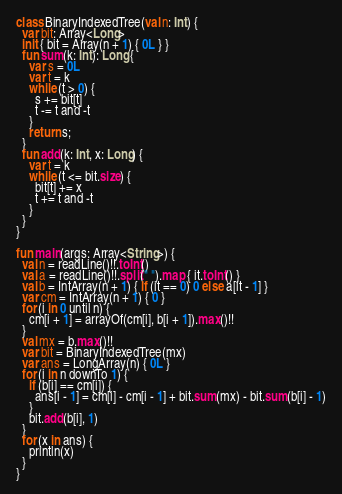<code> <loc_0><loc_0><loc_500><loc_500><_Kotlin_>class BinaryIndexedTree(val n: Int) {
  var bit: Array<Long>
  init { bit = Array(n + 1) { 0L } }
  fun sum(k: Int): Long {
    var s = 0L
    var t = k
    while (t > 0) {
      s += bit[t]
      t -= t and -t
    }
    return s;
  }
  fun add(k: Int, x: Long) {
    var t = k
    while (t <= bit.size) {
      bit[t] += x
      t += t and -t
    }
  }
}

fun main(args: Array<String>) {
  val n = readLine()!!.toInt()
  val a = readLine()!!.split(" ").map { it.toInt() }
  val b = IntArray(n + 1) { if (it == 0) 0 else a[it - 1] }
  var cm = IntArray(n + 1) { 0 }
  for (i in 0 until n) {
    cm[i + 1] = arrayOf(cm[i], b[i + 1]).max()!!
  }
  val mx = b.max()!!
  var bit = BinaryIndexedTree(mx)
  var ans = LongArray(n) { 0L }
  for (i in n downTo 1) {
    if (b[i] == cm[i]) {
      ans[i - 1] = cm[i] - cm[i - 1] + bit.sum(mx) - bit.sum(b[i] - 1)
    }
    bit.add(b[i], 1)
  }
  for (x in ans) {
    println(x)
  }
}
</code> 